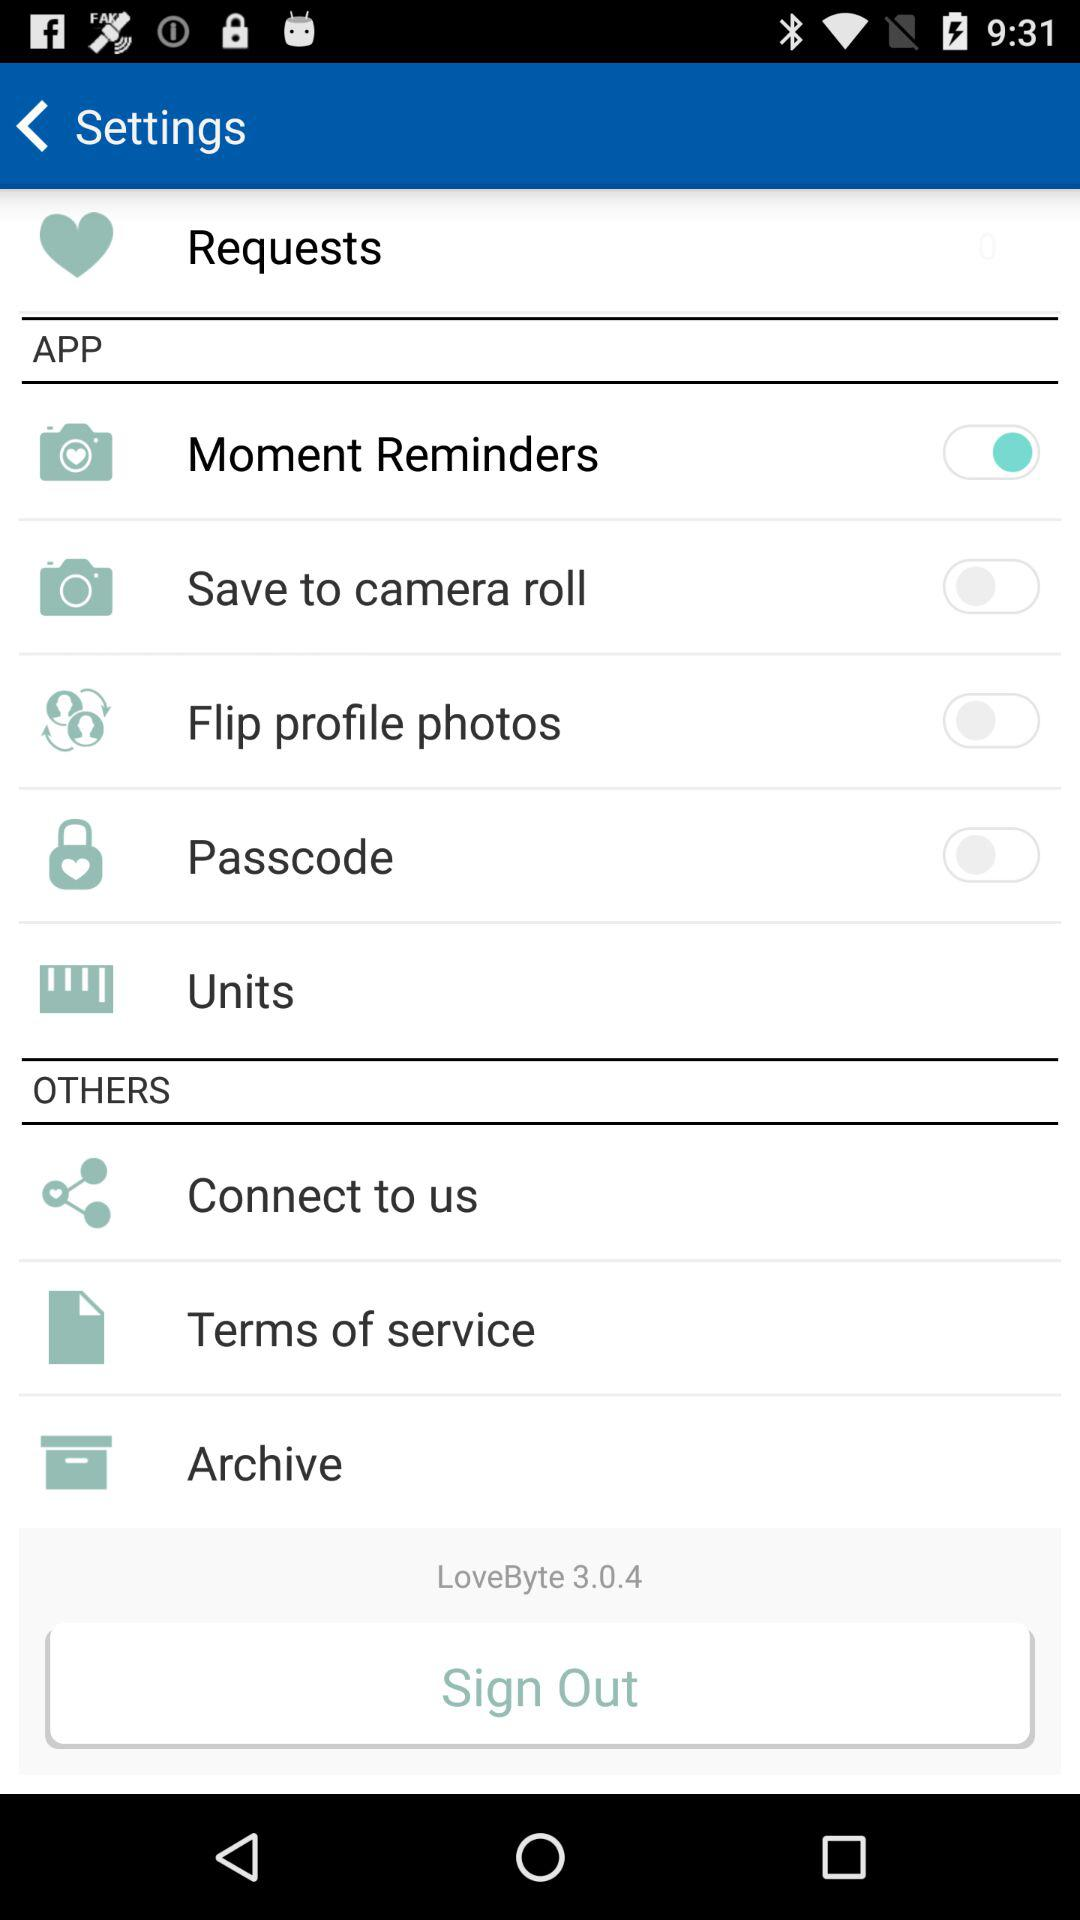Which camera rolls have been archived?
When the provided information is insufficient, respond with <no answer>. <no answer> 